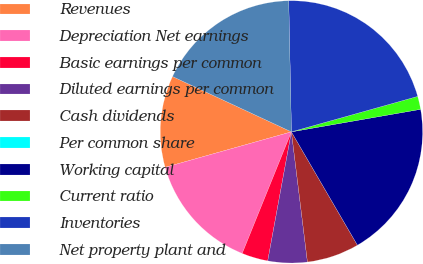Convert chart. <chart><loc_0><loc_0><loc_500><loc_500><pie_chart><fcel>Revenues<fcel>Depreciation Net earnings<fcel>Basic earnings per common<fcel>Diluted earnings per common<fcel>Cash dividends<fcel>Per common share<fcel>Working capital<fcel>Current ratio<fcel>Inventories<fcel>Net property plant and<nl><fcel>11.29%<fcel>14.52%<fcel>3.23%<fcel>4.84%<fcel>6.45%<fcel>0.0%<fcel>19.35%<fcel>1.61%<fcel>20.97%<fcel>17.74%<nl></chart> 